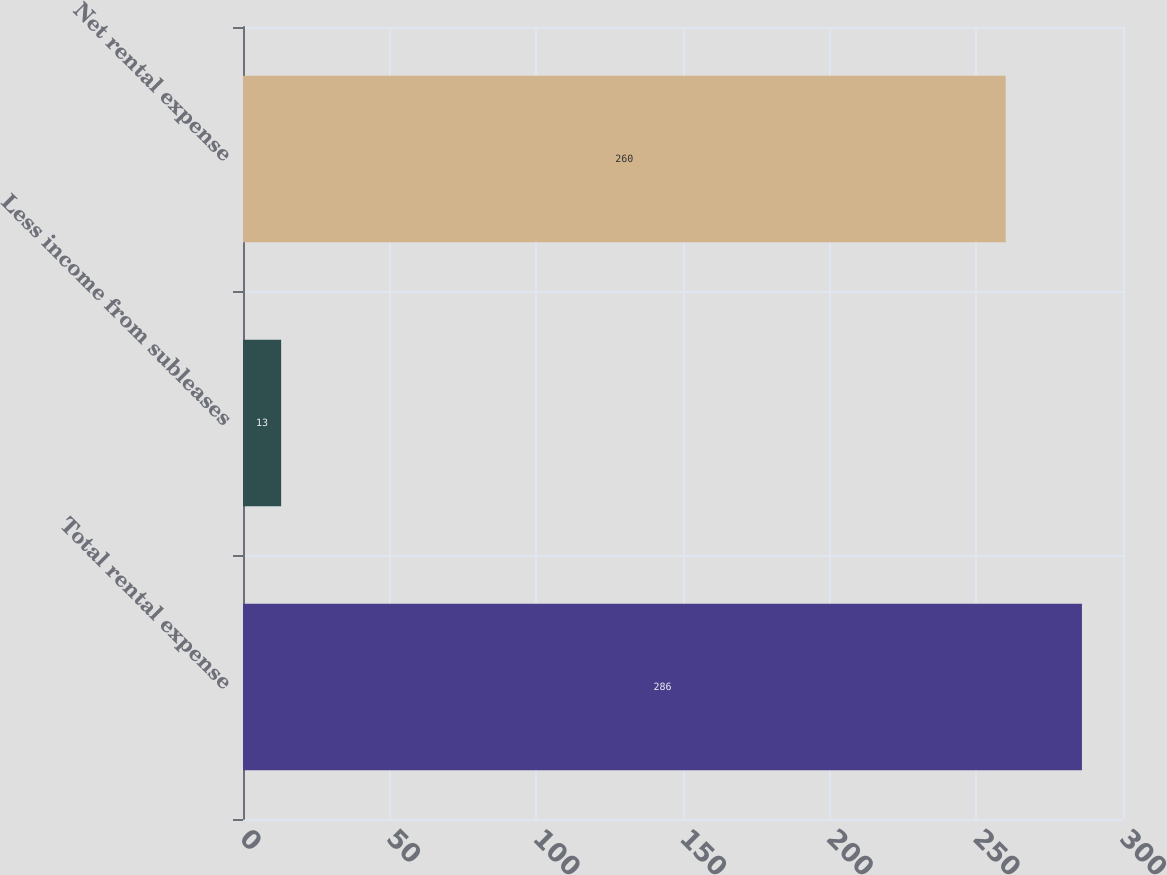<chart> <loc_0><loc_0><loc_500><loc_500><bar_chart><fcel>Total rental expense<fcel>Less income from subleases<fcel>Net rental expense<nl><fcel>286<fcel>13<fcel>260<nl></chart> 